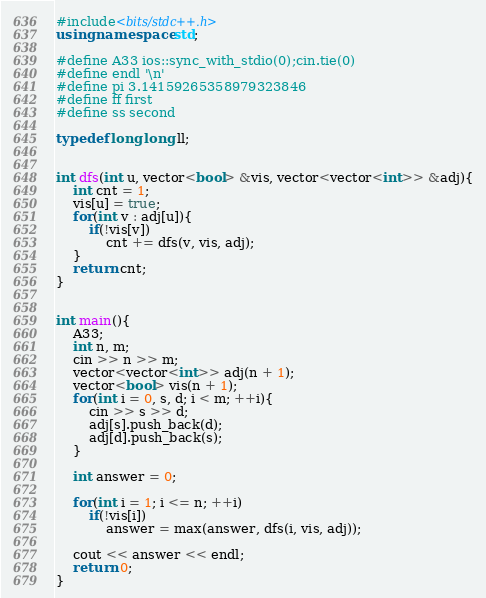<code> <loc_0><loc_0><loc_500><loc_500><_C++_>#include<bits/stdc++.h> 
using namespace std;

#define A33 ios::sync_with_stdio(0);cin.tie(0)
#define endl '\n'
#define pi 3.14159265358979323846
#define ff first
#define ss second

typedef long long ll;


int dfs(int u, vector<bool> &vis, vector<vector<int>> &adj){
	int cnt = 1;
	vis[u] = true;
	for(int v : adj[u]){
		if(!vis[v])
			cnt += dfs(v, vis, adj);
	}
	return cnt;
}


int main(){
	A33;
	int n, m;
	cin >> n >> m;
	vector<vector<int>> adj(n + 1);
	vector<bool> vis(n + 1);
	for(int i = 0, s, d; i < m; ++i){
		cin >> s >> d;
		adj[s].push_back(d);
		adj[d].push_back(s);
	}	

	int answer = 0;

	for(int i = 1; i <= n; ++i)
		if(!vis[i])
			answer = max(answer, dfs(i, vis, adj));
	
	cout << answer << endl;
	return 0;
}</code> 